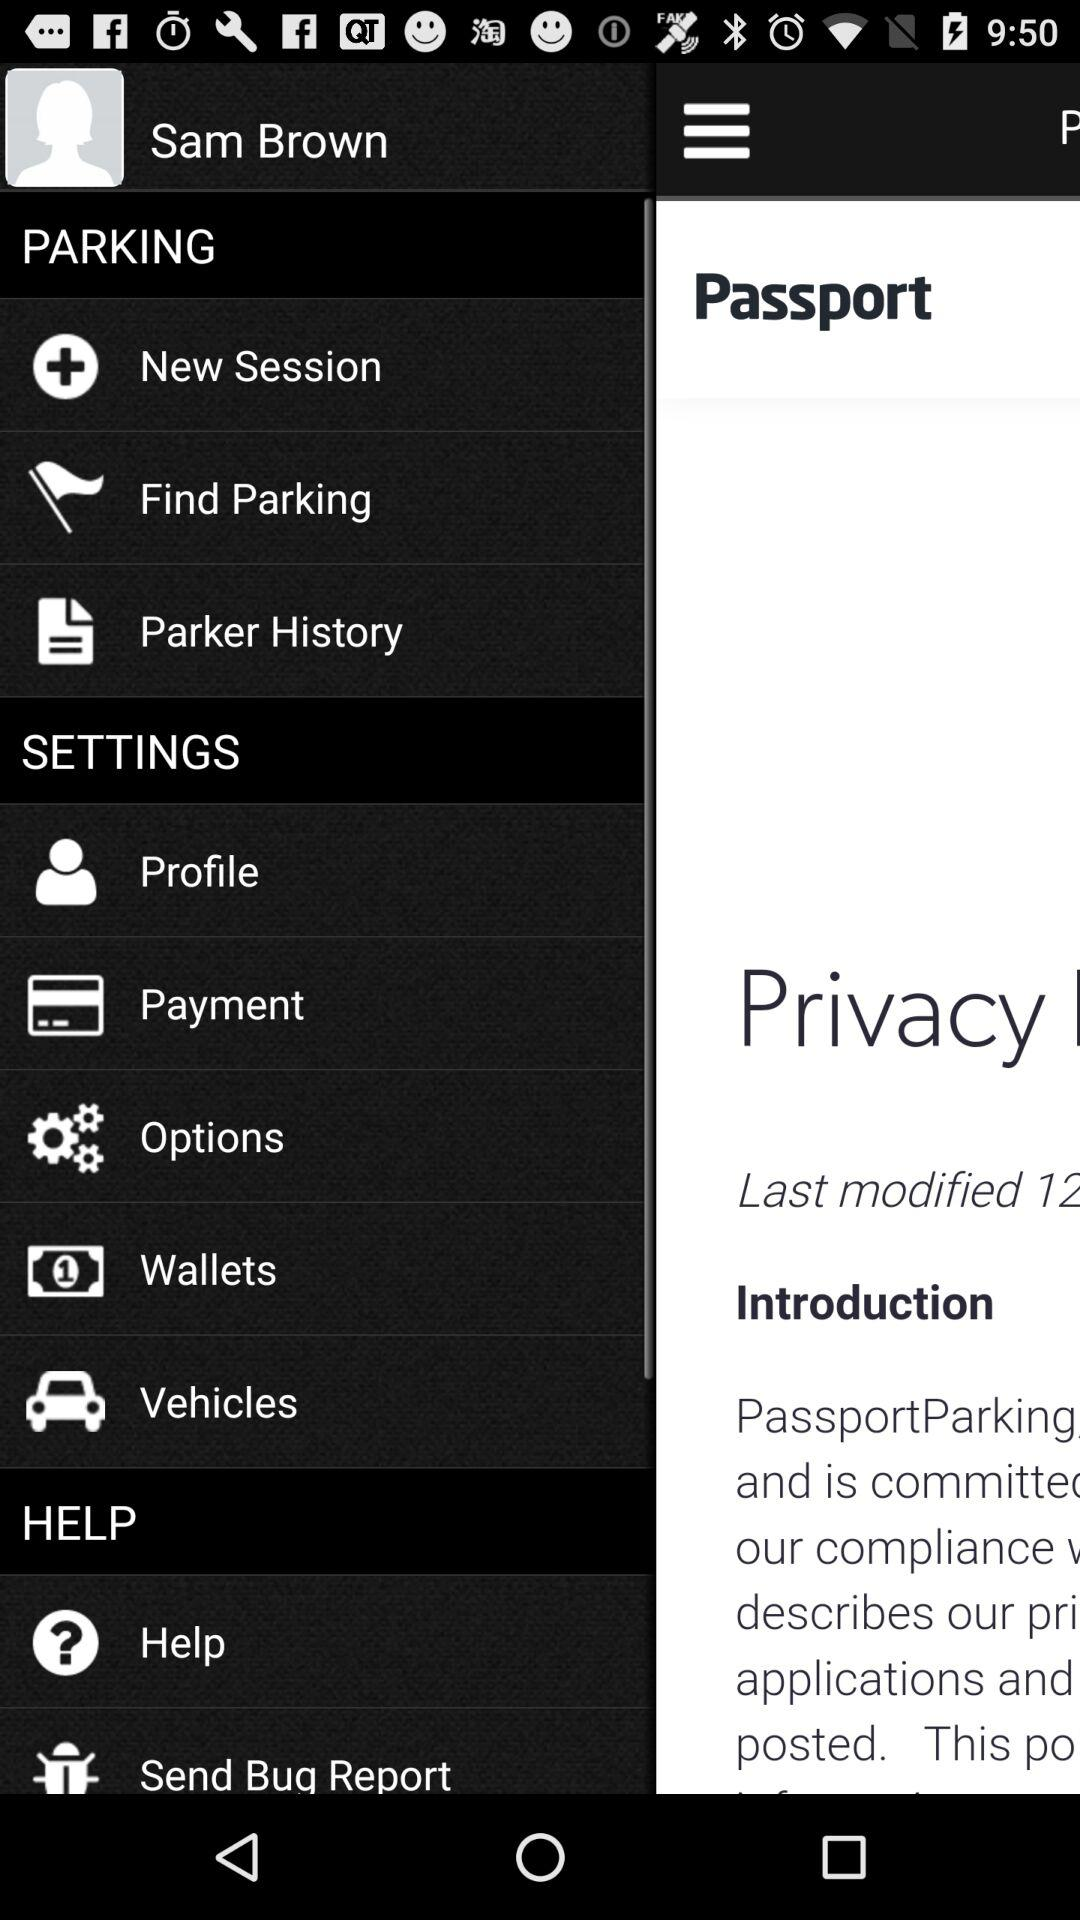How many notifications are there in "Payment"?
When the provided information is insufficient, respond with <no answer>. <no answer> 